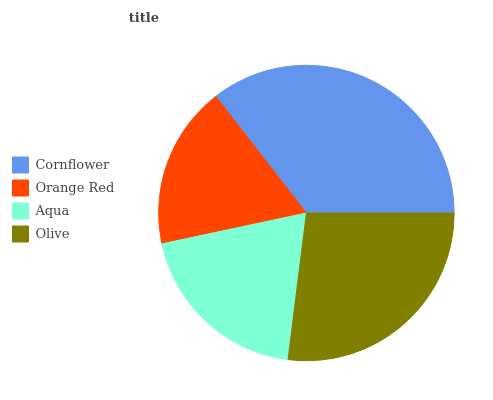Is Orange Red the minimum?
Answer yes or no. Yes. Is Cornflower the maximum?
Answer yes or no. Yes. Is Aqua the minimum?
Answer yes or no. No. Is Aqua the maximum?
Answer yes or no. No. Is Aqua greater than Orange Red?
Answer yes or no. Yes. Is Orange Red less than Aqua?
Answer yes or no. Yes. Is Orange Red greater than Aqua?
Answer yes or no. No. Is Aqua less than Orange Red?
Answer yes or no. No. Is Olive the high median?
Answer yes or no. Yes. Is Aqua the low median?
Answer yes or no. Yes. Is Cornflower the high median?
Answer yes or no. No. Is Olive the low median?
Answer yes or no. No. 